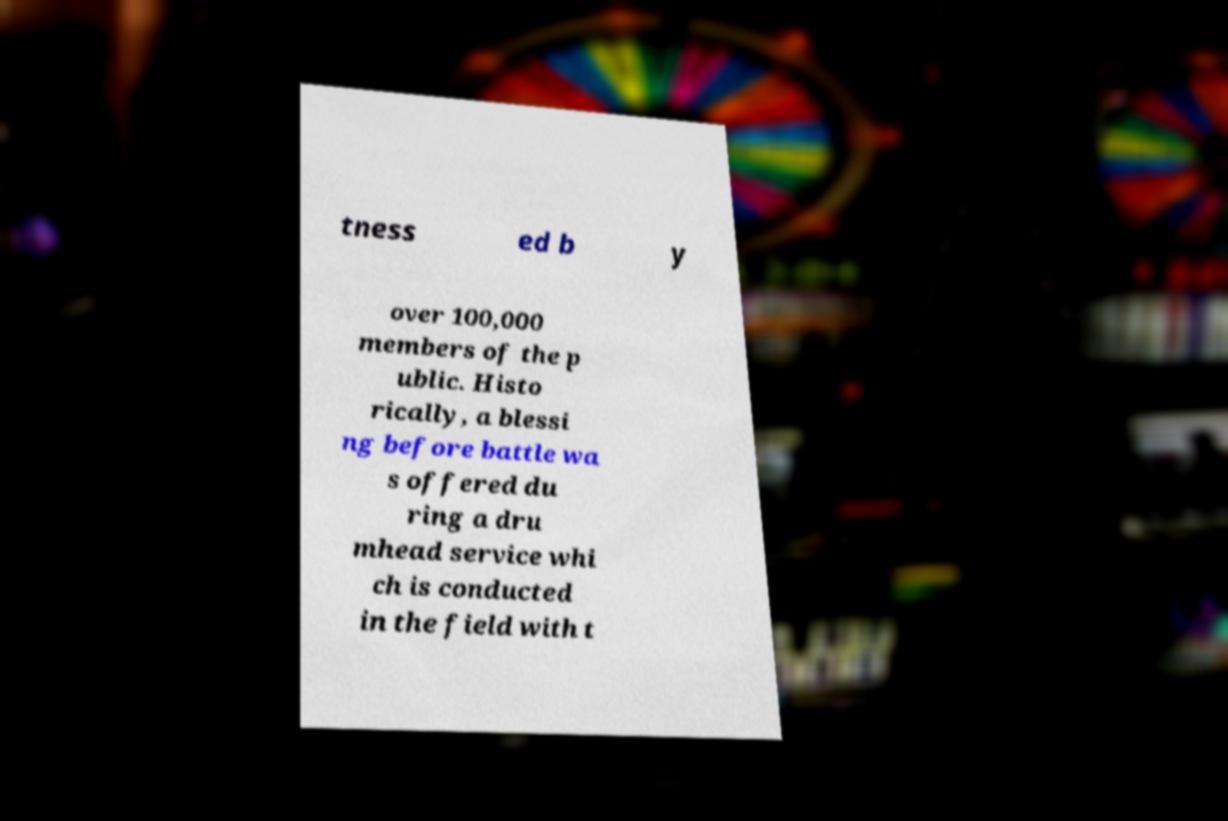Could you assist in decoding the text presented in this image and type it out clearly? tness ed b y over 100,000 members of the p ublic. Histo rically, a blessi ng before battle wa s offered du ring a dru mhead service whi ch is conducted in the field with t 